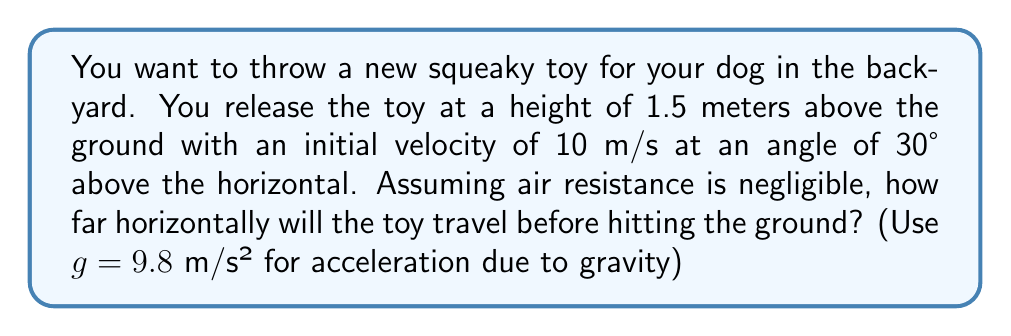Show me your answer to this math problem. To solve this problem, we'll use the equations of projectile motion. Let's break it down step-by-step:

1) First, let's identify the known variables:
   Initial height (h₀) = 1.5 m
   Initial velocity (v₀) = 10 m/s
   Angle (θ) = 30°
   g = 9.8 m/s²

2) We need to find the horizontal distance (x) the toy travels. This is given by:

   $$x = v₀ \cos(θ) \cdot t$$

   where t is the time of flight.

3) To find t, we can use the vertical motion equation:

   $$y = h₀ + v₀ \sin(θ) \cdot t - \frac{1}{2}gt^2$$

4) At the point where the toy hits the ground, y = 0. So we can solve:

   $$0 = 1.5 + 10 \sin(30°) \cdot t - \frac{1}{2}(9.8)t^2$$

5) Simplify:

   $$0 = 1.5 + 5t - 4.9t^2$$

6) This is a quadratic equation. We can solve it using the quadratic formula:

   $$t = \frac{-b \pm \sqrt{b^2 - 4ac}}{2a}$$

   where a = -4.9, b = 5, and c = 1.5

7) Solving this gives us:

   $$t = \frac{-5 + \sqrt{25 + 29.4}}{-9.8} \approx 1.16 \text{ seconds}$$

8) Now that we have t, we can plug it back into the equation for x:

   $$x = 10 \cos(30°) \cdot 1.16$$

9) Simplify:

   $$x = 10 \cdot \frac{\sqrt{3}}{2} \cdot 1.16 \approx 10.05 \text{ meters}$$

Therefore, the toy will travel approximately 10.05 meters horizontally before hitting the ground.
Answer: 10.05 m 